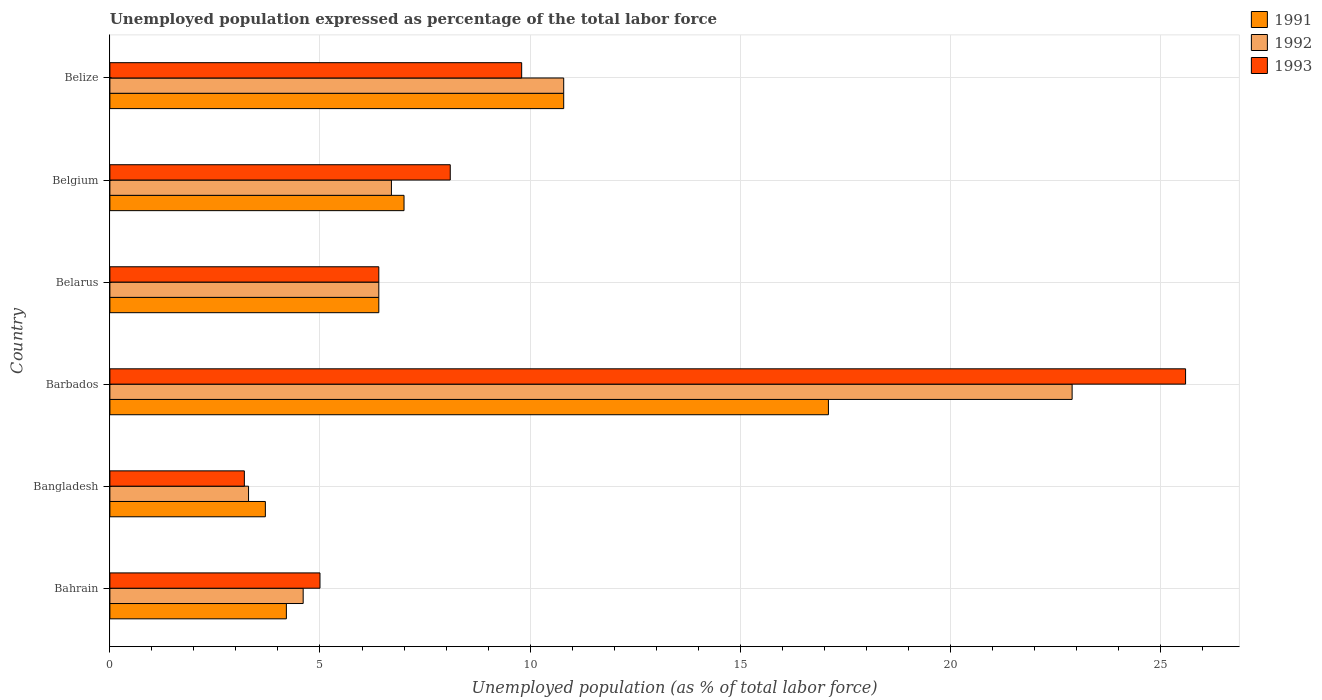How many groups of bars are there?
Ensure brevity in your answer.  6. Are the number of bars per tick equal to the number of legend labels?
Ensure brevity in your answer.  Yes. Are the number of bars on each tick of the Y-axis equal?
Ensure brevity in your answer.  Yes. How many bars are there on the 4th tick from the top?
Give a very brief answer. 3. What is the label of the 2nd group of bars from the top?
Ensure brevity in your answer.  Belgium. In how many cases, is the number of bars for a given country not equal to the number of legend labels?
Your answer should be very brief. 0. What is the unemployment in in 1992 in Belize?
Your response must be concise. 10.8. Across all countries, what is the maximum unemployment in in 1993?
Offer a terse response. 25.6. Across all countries, what is the minimum unemployment in in 1992?
Your answer should be compact. 3.3. In which country was the unemployment in in 1992 maximum?
Offer a terse response. Barbados. In which country was the unemployment in in 1992 minimum?
Offer a very short reply. Bangladesh. What is the total unemployment in in 1991 in the graph?
Provide a succinct answer. 49.2. What is the difference between the unemployment in in 1992 in Bahrain and that in Barbados?
Your answer should be very brief. -18.3. What is the difference between the unemployment in in 1993 in Bangladesh and the unemployment in in 1991 in Barbados?
Ensure brevity in your answer.  -13.9. What is the average unemployment in in 1992 per country?
Offer a very short reply. 9.12. What is the difference between the unemployment in in 1991 and unemployment in in 1992 in Belgium?
Offer a very short reply. 0.3. In how many countries, is the unemployment in in 1992 greater than 16 %?
Ensure brevity in your answer.  1. What is the ratio of the unemployment in in 1993 in Barbados to that in Belgium?
Keep it short and to the point. 3.16. Is the unemployment in in 1991 in Belarus less than that in Belgium?
Give a very brief answer. Yes. What is the difference between the highest and the second highest unemployment in in 1993?
Provide a succinct answer. 15.8. What is the difference between the highest and the lowest unemployment in in 1993?
Offer a very short reply. 22.4. Is the sum of the unemployment in in 1992 in Bangladesh and Belgium greater than the maximum unemployment in in 1993 across all countries?
Provide a succinct answer. No. What does the 2nd bar from the bottom in Barbados represents?
Ensure brevity in your answer.  1992. Is it the case that in every country, the sum of the unemployment in in 1992 and unemployment in in 1993 is greater than the unemployment in in 1991?
Make the answer very short. Yes. How many bars are there?
Provide a succinct answer. 18. Are all the bars in the graph horizontal?
Provide a short and direct response. Yes. How many countries are there in the graph?
Provide a short and direct response. 6. What is the difference between two consecutive major ticks on the X-axis?
Ensure brevity in your answer.  5. Does the graph contain any zero values?
Your answer should be very brief. No. Does the graph contain grids?
Make the answer very short. Yes. Where does the legend appear in the graph?
Provide a short and direct response. Top right. How many legend labels are there?
Provide a succinct answer. 3. How are the legend labels stacked?
Ensure brevity in your answer.  Vertical. What is the title of the graph?
Provide a short and direct response. Unemployed population expressed as percentage of the total labor force. Does "1981" appear as one of the legend labels in the graph?
Offer a terse response. No. What is the label or title of the X-axis?
Your answer should be compact. Unemployed population (as % of total labor force). What is the label or title of the Y-axis?
Make the answer very short. Country. What is the Unemployed population (as % of total labor force) of 1991 in Bahrain?
Keep it short and to the point. 4.2. What is the Unemployed population (as % of total labor force) of 1992 in Bahrain?
Give a very brief answer. 4.6. What is the Unemployed population (as % of total labor force) of 1991 in Bangladesh?
Offer a terse response. 3.7. What is the Unemployed population (as % of total labor force) in 1992 in Bangladesh?
Your response must be concise. 3.3. What is the Unemployed population (as % of total labor force) of 1993 in Bangladesh?
Ensure brevity in your answer.  3.2. What is the Unemployed population (as % of total labor force) in 1991 in Barbados?
Your response must be concise. 17.1. What is the Unemployed population (as % of total labor force) of 1992 in Barbados?
Your answer should be compact. 22.9. What is the Unemployed population (as % of total labor force) of 1993 in Barbados?
Your answer should be very brief. 25.6. What is the Unemployed population (as % of total labor force) of 1991 in Belarus?
Your response must be concise. 6.4. What is the Unemployed population (as % of total labor force) in 1992 in Belarus?
Give a very brief answer. 6.4. What is the Unemployed population (as % of total labor force) in 1993 in Belarus?
Make the answer very short. 6.4. What is the Unemployed population (as % of total labor force) in 1991 in Belgium?
Provide a short and direct response. 7. What is the Unemployed population (as % of total labor force) in 1992 in Belgium?
Your answer should be very brief. 6.7. What is the Unemployed population (as % of total labor force) in 1993 in Belgium?
Ensure brevity in your answer.  8.1. What is the Unemployed population (as % of total labor force) of 1991 in Belize?
Keep it short and to the point. 10.8. What is the Unemployed population (as % of total labor force) in 1992 in Belize?
Your response must be concise. 10.8. What is the Unemployed population (as % of total labor force) of 1993 in Belize?
Your answer should be very brief. 9.8. Across all countries, what is the maximum Unemployed population (as % of total labor force) in 1991?
Offer a very short reply. 17.1. Across all countries, what is the maximum Unemployed population (as % of total labor force) of 1992?
Make the answer very short. 22.9. Across all countries, what is the maximum Unemployed population (as % of total labor force) in 1993?
Your answer should be very brief. 25.6. Across all countries, what is the minimum Unemployed population (as % of total labor force) in 1991?
Provide a succinct answer. 3.7. Across all countries, what is the minimum Unemployed population (as % of total labor force) of 1992?
Ensure brevity in your answer.  3.3. Across all countries, what is the minimum Unemployed population (as % of total labor force) of 1993?
Your answer should be compact. 3.2. What is the total Unemployed population (as % of total labor force) of 1991 in the graph?
Make the answer very short. 49.2. What is the total Unemployed population (as % of total labor force) in 1992 in the graph?
Keep it short and to the point. 54.7. What is the total Unemployed population (as % of total labor force) of 1993 in the graph?
Ensure brevity in your answer.  58.1. What is the difference between the Unemployed population (as % of total labor force) of 1991 in Bahrain and that in Bangladesh?
Keep it short and to the point. 0.5. What is the difference between the Unemployed population (as % of total labor force) of 1992 in Bahrain and that in Bangladesh?
Offer a terse response. 1.3. What is the difference between the Unemployed population (as % of total labor force) in 1993 in Bahrain and that in Bangladesh?
Offer a terse response. 1.8. What is the difference between the Unemployed population (as % of total labor force) in 1992 in Bahrain and that in Barbados?
Your answer should be very brief. -18.3. What is the difference between the Unemployed population (as % of total labor force) of 1993 in Bahrain and that in Barbados?
Give a very brief answer. -20.6. What is the difference between the Unemployed population (as % of total labor force) of 1992 in Bahrain and that in Belarus?
Offer a terse response. -1.8. What is the difference between the Unemployed population (as % of total labor force) of 1992 in Bahrain and that in Belgium?
Ensure brevity in your answer.  -2.1. What is the difference between the Unemployed population (as % of total labor force) of 1991 in Bahrain and that in Belize?
Provide a short and direct response. -6.6. What is the difference between the Unemployed population (as % of total labor force) in 1993 in Bahrain and that in Belize?
Provide a short and direct response. -4.8. What is the difference between the Unemployed population (as % of total labor force) in 1992 in Bangladesh and that in Barbados?
Your response must be concise. -19.6. What is the difference between the Unemployed population (as % of total labor force) in 1993 in Bangladesh and that in Barbados?
Keep it short and to the point. -22.4. What is the difference between the Unemployed population (as % of total labor force) in 1992 in Bangladesh and that in Belarus?
Your answer should be compact. -3.1. What is the difference between the Unemployed population (as % of total labor force) of 1993 in Bangladesh and that in Belarus?
Your answer should be compact. -3.2. What is the difference between the Unemployed population (as % of total labor force) in 1992 in Bangladesh and that in Belgium?
Give a very brief answer. -3.4. What is the difference between the Unemployed population (as % of total labor force) of 1991 in Bangladesh and that in Belize?
Offer a very short reply. -7.1. What is the difference between the Unemployed population (as % of total labor force) in 1992 in Bangladesh and that in Belize?
Your answer should be very brief. -7.5. What is the difference between the Unemployed population (as % of total labor force) of 1993 in Bangladesh and that in Belize?
Your response must be concise. -6.6. What is the difference between the Unemployed population (as % of total labor force) in 1991 in Barbados and that in Belarus?
Offer a terse response. 10.7. What is the difference between the Unemployed population (as % of total labor force) in 1992 in Barbados and that in Belarus?
Make the answer very short. 16.5. What is the difference between the Unemployed population (as % of total labor force) of 1993 in Barbados and that in Belarus?
Your response must be concise. 19.2. What is the difference between the Unemployed population (as % of total labor force) in 1992 in Barbados and that in Belgium?
Give a very brief answer. 16.2. What is the difference between the Unemployed population (as % of total labor force) in 1991 in Barbados and that in Belize?
Keep it short and to the point. 6.3. What is the difference between the Unemployed population (as % of total labor force) of 1992 in Barbados and that in Belize?
Offer a terse response. 12.1. What is the difference between the Unemployed population (as % of total labor force) of 1993 in Barbados and that in Belize?
Ensure brevity in your answer.  15.8. What is the difference between the Unemployed population (as % of total labor force) of 1991 in Belarus and that in Belgium?
Your answer should be very brief. -0.6. What is the difference between the Unemployed population (as % of total labor force) in 1992 in Belarus and that in Belize?
Keep it short and to the point. -4.4. What is the difference between the Unemployed population (as % of total labor force) in 1992 in Belgium and that in Belize?
Provide a short and direct response. -4.1. What is the difference between the Unemployed population (as % of total labor force) in 1991 in Bahrain and the Unemployed population (as % of total labor force) in 1992 in Bangladesh?
Offer a very short reply. 0.9. What is the difference between the Unemployed population (as % of total labor force) in 1991 in Bahrain and the Unemployed population (as % of total labor force) in 1993 in Bangladesh?
Offer a terse response. 1. What is the difference between the Unemployed population (as % of total labor force) of 1991 in Bahrain and the Unemployed population (as % of total labor force) of 1992 in Barbados?
Make the answer very short. -18.7. What is the difference between the Unemployed population (as % of total labor force) of 1991 in Bahrain and the Unemployed population (as % of total labor force) of 1993 in Barbados?
Your response must be concise. -21.4. What is the difference between the Unemployed population (as % of total labor force) of 1992 in Bahrain and the Unemployed population (as % of total labor force) of 1993 in Barbados?
Keep it short and to the point. -21. What is the difference between the Unemployed population (as % of total labor force) of 1991 in Bahrain and the Unemployed population (as % of total labor force) of 1992 in Belarus?
Offer a terse response. -2.2. What is the difference between the Unemployed population (as % of total labor force) in 1992 in Bahrain and the Unemployed population (as % of total labor force) in 1993 in Belarus?
Ensure brevity in your answer.  -1.8. What is the difference between the Unemployed population (as % of total labor force) in 1991 in Bahrain and the Unemployed population (as % of total labor force) in 1992 in Belgium?
Offer a very short reply. -2.5. What is the difference between the Unemployed population (as % of total labor force) in 1992 in Bahrain and the Unemployed population (as % of total labor force) in 1993 in Belgium?
Your response must be concise. -3.5. What is the difference between the Unemployed population (as % of total labor force) of 1991 in Bahrain and the Unemployed population (as % of total labor force) of 1992 in Belize?
Offer a terse response. -6.6. What is the difference between the Unemployed population (as % of total labor force) of 1991 in Bangladesh and the Unemployed population (as % of total labor force) of 1992 in Barbados?
Keep it short and to the point. -19.2. What is the difference between the Unemployed population (as % of total labor force) in 1991 in Bangladesh and the Unemployed population (as % of total labor force) in 1993 in Barbados?
Your answer should be compact. -21.9. What is the difference between the Unemployed population (as % of total labor force) of 1992 in Bangladesh and the Unemployed population (as % of total labor force) of 1993 in Barbados?
Offer a terse response. -22.3. What is the difference between the Unemployed population (as % of total labor force) of 1991 in Bangladesh and the Unemployed population (as % of total labor force) of 1993 in Belarus?
Ensure brevity in your answer.  -2.7. What is the difference between the Unemployed population (as % of total labor force) in 1991 in Bangladesh and the Unemployed population (as % of total labor force) in 1992 in Belgium?
Your response must be concise. -3. What is the difference between the Unemployed population (as % of total labor force) of 1991 in Bangladesh and the Unemployed population (as % of total labor force) of 1993 in Belize?
Give a very brief answer. -6.1. What is the difference between the Unemployed population (as % of total labor force) in 1992 in Barbados and the Unemployed population (as % of total labor force) in 1993 in Belarus?
Keep it short and to the point. 16.5. What is the difference between the Unemployed population (as % of total labor force) in 1991 in Barbados and the Unemployed population (as % of total labor force) in 1993 in Belize?
Give a very brief answer. 7.3. What is the difference between the Unemployed population (as % of total labor force) of 1992 in Barbados and the Unemployed population (as % of total labor force) of 1993 in Belize?
Ensure brevity in your answer.  13.1. What is the difference between the Unemployed population (as % of total labor force) in 1991 in Belarus and the Unemployed population (as % of total labor force) in 1992 in Belgium?
Make the answer very short. -0.3. What is the difference between the Unemployed population (as % of total labor force) of 1991 in Belarus and the Unemployed population (as % of total labor force) of 1993 in Belgium?
Make the answer very short. -1.7. What is the difference between the Unemployed population (as % of total labor force) in 1992 in Belarus and the Unemployed population (as % of total labor force) in 1993 in Belgium?
Your response must be concise. -1.7. What is the difference between the Unemployed population (as % of total labor force) in 1991 in Belarus and the Unemployed population (as % of total labor force) in 1992 in Belize?
Give a very brief answer. -4.4. What is the difference between the Unemployed population (as % of total labor force) in 1991 in Belgium and the Unemployed population (as % of total labor force) in 1992 in Belize?
Make the answer very short. -3.8. What is the difference between the Unemployed population (as % of total labor force) of 1991 in Belgium and the Unemployed population (as % of total labor force) of 1993 in Belize?
Your response must be concise. -2.8. What is the average Unemployed population (as % of total labor force) in 1991 per country?
Offer a very short reply. 8.2. What is the average Unemployed population (as % of total labor force) in 1992 per country?
Your response must be concise. 9.12. What is the average Unemployed population (as % of total labor force) in 1993 per country?
Ensure brevity in your answer.  9.68. What is the difference between the Unemployed population (as % of total labor force) of 1991 and Unemployed population (as % of total labor force) of 1992 in Bangladesh?
Offer a terse response. 0.4. What is the difference between the Unemployed population (as % of total labor force) in 1991 and Unemployed population (as % of total labor force) in 1993 in Bangladesh?
Offer a terse response. 0.5. What is the difference between the Unemployed population (as % of total labor force) in 1991 and Unemployed population (as % of total labor force) in 1992 in Barbados?
Offer a very short reply. -5.8. What is the difference between the Unemployed population (as % of total labor force) of 1991 and Unemployed population (as % of total labor force) of 1993 in Barbados?
Your answer should be very brief. -8.5. What is the difference between the Unemployed population (as % of total labor force) in 1992 and Unemployed population (as % of total labor force) in 1993 in Barbados?
Make the answer very short. -2.7. What is the difference between the Unemployed population (as % of total labor force) of 1991 and Unemployed population (as % of total labor force) of 1992 in Belarus?
Keep it short and to the point. 0. What is the difference between the Unemployed population (as % of total labor force) of 1991 and Unemployed population (as % of total labor force) of 1993 in Belgium?
Your response must be concise. -1.1. What is the difference between the Unemployed population (as % of total labor force) in 1992 and Unemployed population (as % of total labor force) in 1993 in Belgium?
Give a very brief answer. -1.4. What is the difference between the Unemployed population (as % of total labor force) in 1991 and Unemployed population (as % of total labor force) in 1993 in Belize?
Offer a very short reply. 1. What is the ratio of the Unemployed population (as % of total labor force) in 1991 in Bahrain to that in Bangladesh?
Provide a short and direct response. 1.14. What is the ratio of the Unemployed population (as % of total labor force) of 1992 in Bahrain to that in Bangladesh?
Ensure brevity in your answer.  1.39. What is the ratio of the Unemployed population (as % of total labor force) of 1993 in Bahrain to that in Bangladesh?
Offer a terse response. 1.56. What is the ratio of the Unemployed population (as % of total labor force) in 1991 in Bahrain to that in Barbados?
Make the answer very short. 0.25. What is the ratio of the Unemployed population (as % of total labor force) of 1992 in Bahrain to that in Barbados?
Provide a succinct answer. 0.2. What is the ratio of the Unemployed population (as % of total labor force) of 1993 in Bahrain to that in Barbados?
Keep it short and to the point. 0.2. What is the ratio of the Unemployed population (as % of total labor force) of 1991 in Bahrain to that in Belarus?
Offer a terse response. 0.66. What is the ratio of the Unemployed population (as % of total labor force) of 1992 in Bahrain to that in Belarus?
Give a very brief answer. 0.72. What is the ratio of the Unemployed population (as % of total labor force) in 1993 in Bahrain to that in Belarus?
Your answer should be compact. 0.78. What is the ratio of the Unemployed population (as % of total labor force) of 1992 in Bahrain to that in Belgium?
Your response must be concise. 0.69. What is the ratio of the Unemployed population (as % of total labor force) in 1993 in Bahrain to that in Belgium?
Keep it short and to the point. 0.62. What is the ratio of the Unemployed population (as % of total labor force) of 1991 in Bahrain to that in Belize?
Keep it short and to the point. 0.39. What is the ratio of the Unemployed population (as % of total labor force) of 1992 in Bahrain to that in Belize?
Offer a terse response. 0.43. What is the ratio of the Unemployed population (as % of total labor force) in 1993 in Bahrain to that in Belize?
Ensure brevity in your answer.  0.51. What is the ratio of the Unemployed population (as % of total labor force) in 1991 in Bangladesh to that in Barbados?
Offer a very short reply. 0.22. What is the ratio of the Unemployed population (as % of total labor force) of 1992 in Bangladesh to that in Barbados?
Give a very brief answer. 0.14. What is the ratio of the Unemployed population (as % of total labor force) in 1991 in Bangladesh to that in Belarus?
Make the answer very short. 0.58. What is the ratio of the Unemployed population (as % of total labor force) of 1992 in Bangladesh to that in Belarus?
Your answer should be very brief. 0.52. What is the ratio of the Unemployed population (as % of total labor force) of 1993 in Bangladesh to that in Belarus?
Make the answer very short. 0.5. What is the ratio of the Unemployed population (as % of total labor force) in 1991 in Bangladesh to that in Belgium?
Your response must be concise. 0.53. What is the ratio of the Unemployed population (as % of total labor force) in 1992 in Bangladesh to that in Belgium?
Provide a short and direct response. 0.49. What is the ratio of the Unemployed population (as % of total labor force) of 1993 in Bangladesh to that in Belgium?
Keep it short and to the point. 0.4. What is the ratio of the Unemployed population (as % of total labor force) in 1991 in Bangladesh to that in Belize?
Your response must be concise. 0.34. What is the ratio of the Unemployed population (as % of total labor force) of 1992 in Bangladesh to that in Belize?
Provide a succinct answer. 0.31. What is the ratio of the Unemployed population (as % of total labor force) in 1993 in Bangladesh to that in Belize?
Make the answer very short. 0.33. What is the ratio of the Unemployed population (as % of total labor force) in 1991 in Barbados to that in Belarus?
Give a very brief answer. 2.67. What is the ratio of the Unemployed population (as % of total labor force) of 1992 in Barbados to that in Belarus?
Provide a short and direct response. 3.58. What is the ratio of the Unemployed population (as % of total labor force) in 1991 in Barbados to that in Belgium?
Provide a succinct answer. 2.44. What is the ratio of the Unemployed population (as % of total labor force) in 1992 in Barbados to that in Belgium?
Offer a very short reply. 3.42. What is the ratio of the Unemployed population (as % of total labor force) of 1993 in Barbados to that in Belgium?
Provide a short and direct response. 3.16. What is the ratio of the Unemployed population (as % of total labor force) of 1991 in Barbados to that in Belize?
Provide a succinct answer. 1.58. What is the ratio of the Unemployed population (as % of total labor force) of 1992 in Barbados to that in Belize?
Your response must be concise. 2.12. What is the ratio of the Unemployed population (as % of total labor force) in 1993 in Barbados to that in Belize?
Offer a very short reply. 2.61. What is the ratio of the Unemployed population (as % of total labor force) in 1991 in Belarus to that in Belgium?
Keep it short and to the point. 0.91. What is the ratio of the Unemployed population (as % of total labor force) of 1992 in Belarus to that in Belgium?
Your response must be concise. 0.96. What is the ratio of the Unemployed population (as % of total labor force) in 1993 in Belarus to that in Belgium?
Make the answer very short. 0.79. What is the ratio of the Unemployed population (as % of total labor force) of 1991 in Belarus to that in Belize?
Offer a very short reply. 0.59. What is the ratio of the Unemployed population (as % of total labor force) of 1992 in Belarus to that in Belize?
Give a very brief answer. 0.59. What is the ratio of the Unemployed population (as % of total labor force) in 1993 in Belarus to that in Belize?
Ensure brevity in your answer.  0.65. What is the ratio of the Unemployed population (as % of total labor force) in 1991 in Belgium to that in Belize?
Provide a short and direct response. 0.65. What is the ratio of the Unemployed population (as % of total labor force) of 1992 in Belgium to that in Belize?
Make the answer very short. 0.62. What is the ratio of the Unemployed population (as % of total labor force) of 1993 in Belgium to that in Belize?
Provide a short and direct response. 0.83. What is the difference between the highest and the second highest Unemployed population (as % of total labor force) of 1992?
Provide a succinct answer. 12.1. What is the difference between the highest and the second highest Unemployed population (as % of total labor force) of 1993?
Give a very brief answer. 15.8. What is the difference between the highest and the lowest Unemployed population (as % of total labor force) of 1992?
Make the answer very short. 19.6. What is the difference between the highest and the lowest Unemployed population (as % of total labor force) in 1993?
Keep it short and to the point. 22.4. 